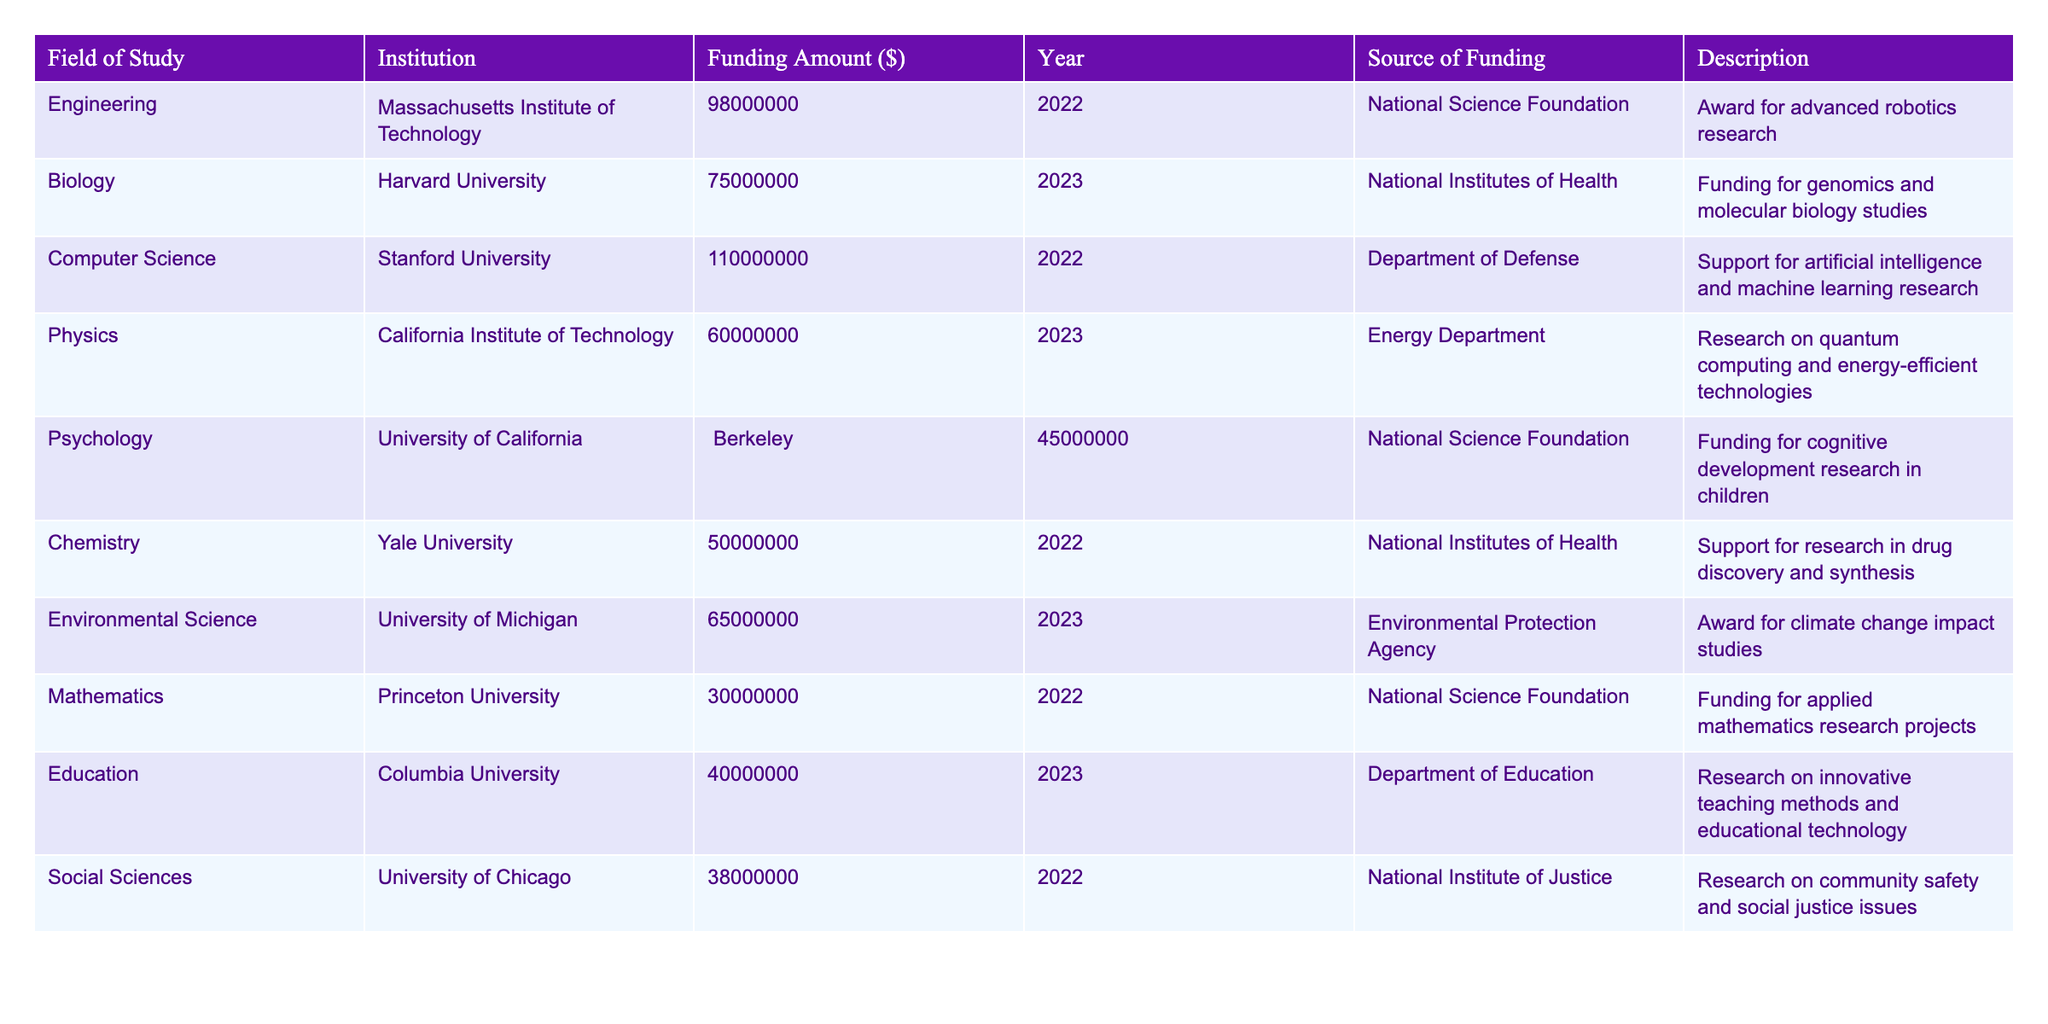What is the total funding amount for Biology research? The funding amount for Biology at Harvard University is $75,000,000. Therefore, the total funding amount specifically for the Biology field of study is $75,000,000.
Answer: 75,000,000 Which institution received the highest funding for Computer Science? The institution that received the highest funding for Computer Science is Stanford University with an amount of $110,000,000.
Answer: Stanford University What year did the University of California, Berkeley receive funding for Psychology? The University of California, Berkeley received funding for Psychology in the year 2023.
Answer: 2023 How much more funding did the Massachusetts Institute of Technology receive for Engineering compared to Princeton University's Mathematics funding? Massachusetts Institute of Technology received $98,000,000 for Engineering, while Princeton University received $30,000,000 for Mathematics. The difference is $98,000,000 - $30,000,000 = $68,000,000.
Answer: 68,000,000 Is the funding for Environmental Science at the University of Michigan greater than that for Physics at the California Institute of Technology? The funding amount for Environmental Science ($65,000,000) is compared to Physics funding ($60,000,000). Since $65,000,000 > $60,000,000, the statement is true.
Answer: Yes What are the total funding amounts from the National Science Foundation across all fields? The National Science Foundation provided funding for Engineering ($98,000,000), Psychology ($45,000,000), and Mathematics ($30,000,000). The total is $98,000,000 + $45,000,000 + $30,000,000 = $173,000,000.
Answer: 173,000,000 Which field of study has the lowest funding amount and what is that amount? Reviewing the table, Mathematics at Princeton University has the lowest funding amount of $30,000,000.
Answer: Mathematics, 30,000,000 What is the average funding amount across all fields listed in the table? The total funding amounts for all fields is $480,000,000 (sum of all funding amounts), and there are 10 fields. The average funding amount is $480,000,000 / 10 = $48,000,000.
Answer: 48,000,000 Which funding source supported the highest amount for research in any field? The highest single funding amount was from the Department of Defense for Computer Science at Stanford University, which is $110,000,000.
Answer: Department of Defense Compare the funding for Drug Discovery and Psychology research. Which one received more? Chemistry (Drug Discovery) received $50,000,000, while Psychology received $45,000,000. Since $50,000,000 > $45,000,000, Drug Discovery received more funding.
Answer: Drug Discovery How much total funding was allocated for research in fields starting with the letter 'E'? The only field starting with 'E' is Environmental Science, which received $65,000,000, so the total is $65,000,000.
Answer: 65,000,000 